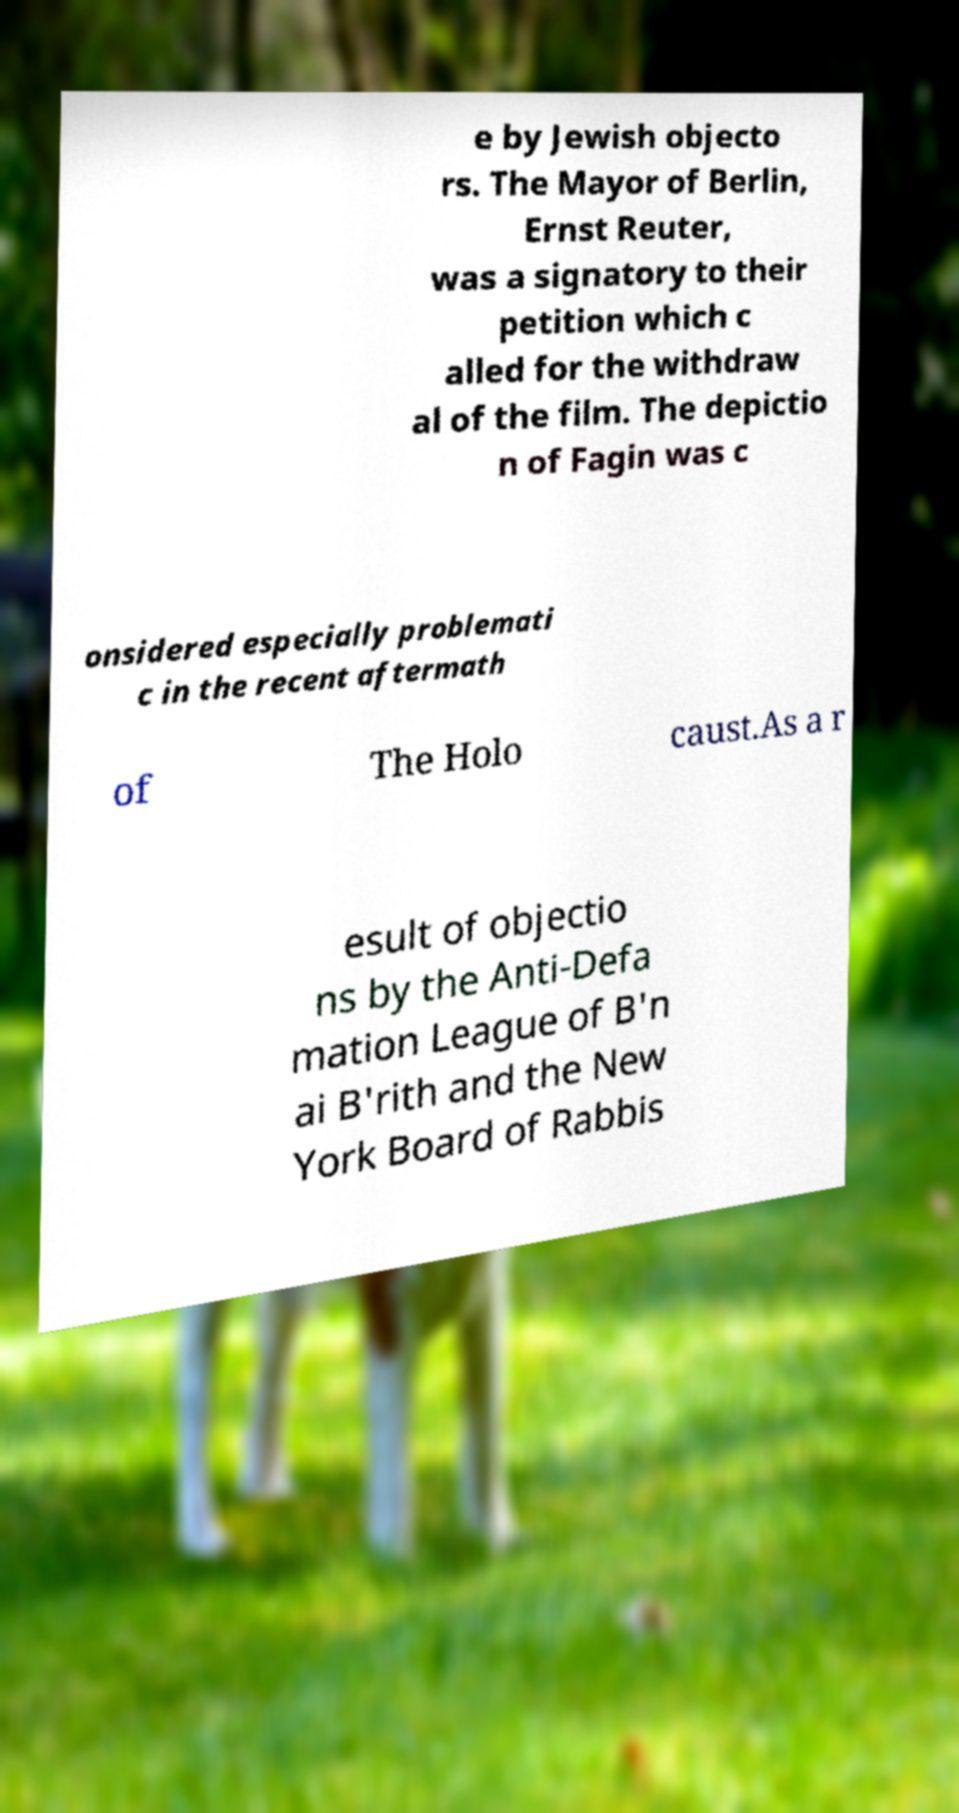For documentation purposes, I need the text within this image transcribed. Could you provide that? e by Jewish objecto rs. The Mayor of Berlin, Ernst Reuter, was a signatory to their petition which c alled for the withdraw al of the film. The depictio n of Fagin was c onsidered especially problemati c in the recent aftermath of The Holo caust.As a r esult of objectio ns by the Anti-Defa mation League of B'n ai B'rith and the New York Board of Rabbis 